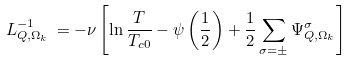Convert formula to latex. <formula><loc_0><loc_0><loc_500><loc_500>L ^ { - 1 } _ { Q , \Omega _ { k } } \, = - \nu \left [ \ln \frac { T } { T _ { c 0 } } - \psi \left ( \frac { 1 } { 2 } \right ) + \frac { 1 } { 2 } \sum _ { \sigma = \pm } \Psi ^ { \sigma } _ { Q , \Omega _ { k } } \right ]</formula> 